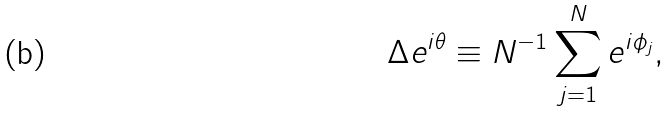Convert formula to latex. <formula><loc_0><loc_0><loc_500><loc_500>\Delta e ^ { i \theta } \equiv N ^ { - 1 } \sum _ { j = 1 } ^ { N } e ^ { i \phi _ { j } } ,</formula> 